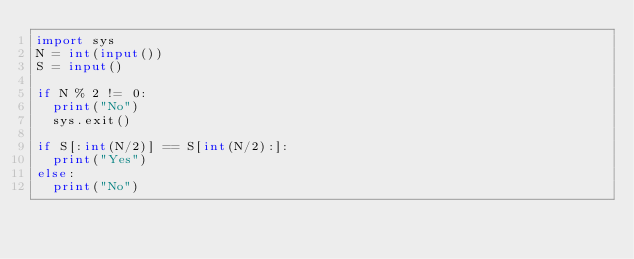Convert code to text. <code><loc_0><loc_0><loc_500><loc_500><_Python_>import sys
N = int(input())
S = input()

if N % 2 != 0:
  print("No")
  sys.exit()
  
if S[:int(N/2)] == S[int(N/2):]:
  print("Yes")
else:
  print("No")
  </code> 